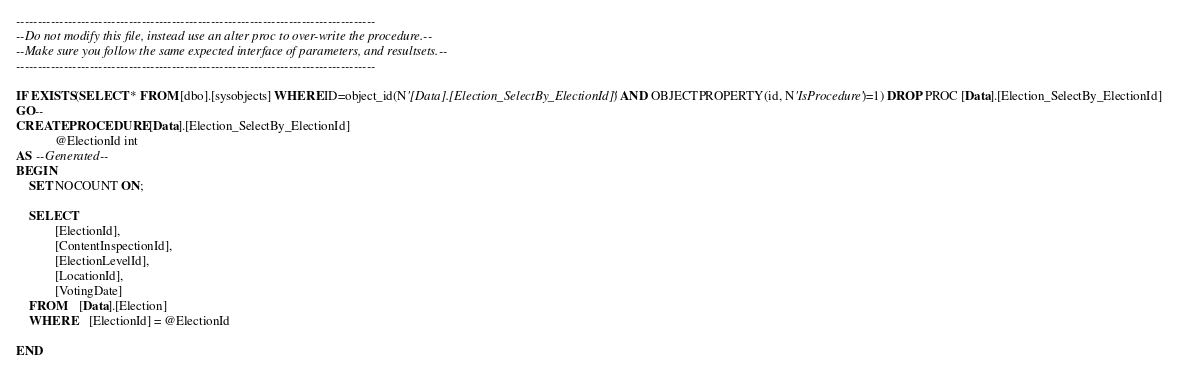<code> <loc_0><loc_0><loc_500><loc_500><_SQL_>-----------------------------------------------------------------------------------
--Do not modify this file, instead use an alter proc to over-write the procedure.--
--Make sure you follow the same expected interface of parameters, and resultsets.--
-----------------------------------------------------------------------------------

IF EXISTS(SELECT * FROM [dbo].[sysobjects] WHERE ID=object_id(N'[Data].[Election_SelectBy_ElectionId]') AND OBJECTPROPERTY(id, N'IsProcedure')=1) DROP PROC [Data].[Election_SelectBy_ElectionId]
GO--
CREATE PROCEDURE [Data].[Election_SelectBy_ElectionId] 
			@ElectionId int
AS --Generated--
BEGIN
	SET NOCOUNT ON;

	SELECT	
			[ElectionId],
			[ContentInspectionId],
			[ElectionLevelId],
			[LocationId],
			[VotingDate]
	FROM	[Data].[Election]
	WHERE	[ElectionId] = @ElectionId

END</code> 